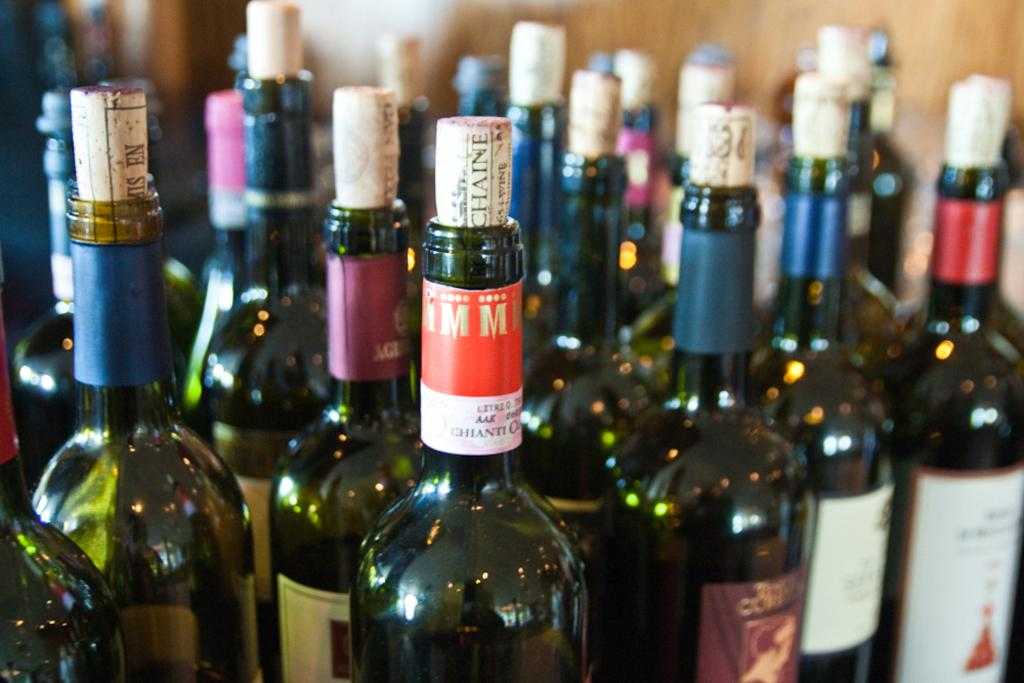What objects are present in the image in a group? There is a group of bottles in the image. What feature do all the bottles have in common? Each bottle has a cork. How can the bottles be identified or distinguished from one another? Each bottle has a label. What type of butter is being used to create a memory in the image? There is no butter or memory present in the image; it features a group of bottles with corks and labels. 